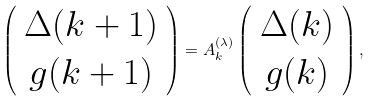<formula> <loc_0><loc_0><loc_500><loc_500>\left ( \begin{array} { c } \Delta ( k + 1 ) \\ g ( k + 1 ) \end{array} \right ) = A _ { k } ^ { ( \lambda ) } \left ( \begin{array} { c } \Delta ( k ) \\ g ( k ) \end{array} \right ) ,</formula> 